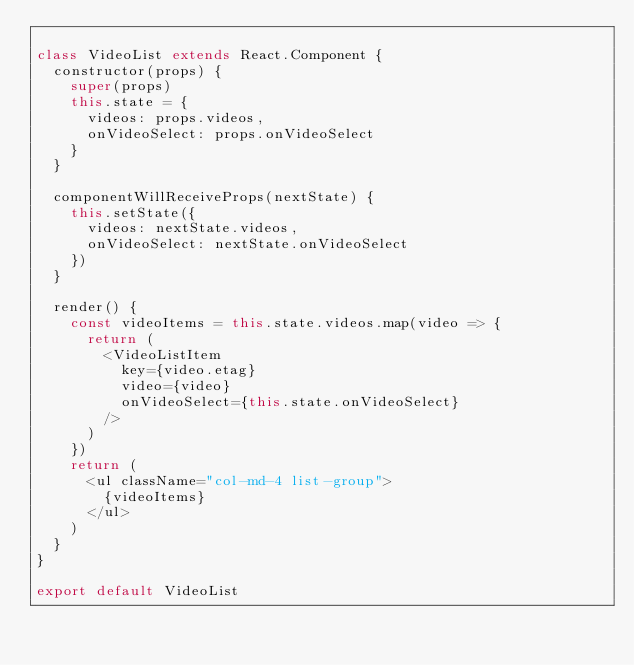<code> <loc_0><loc_0><loc_500><loc_500><_JavaScript_>
class VideoList extends React.Component {
  constructor(props) {
    super(props)
    this.state = {
      videos: props.videos,
      onVideoSelect: props.onVideoSelect
    }
  }

  componentWillReceiveProps(nextState) {
    this.setState({
      videos: nextState.videos,
      onVideoSelect: nextState.onVideoSelect
    })
  }

  render() {
    const videoItems = this.state.videos.map(video => {
      return (
        <VideoListItem
          key={video.etag}
          video={video}
          onVideoSelect={this.state.onVideoSelect}
        />
      )
    })
    return (
      <ul className="col-md-4 list-group">
        {videoItems}
      </ul>
    )
  }
}

export default VideoList
</code> 